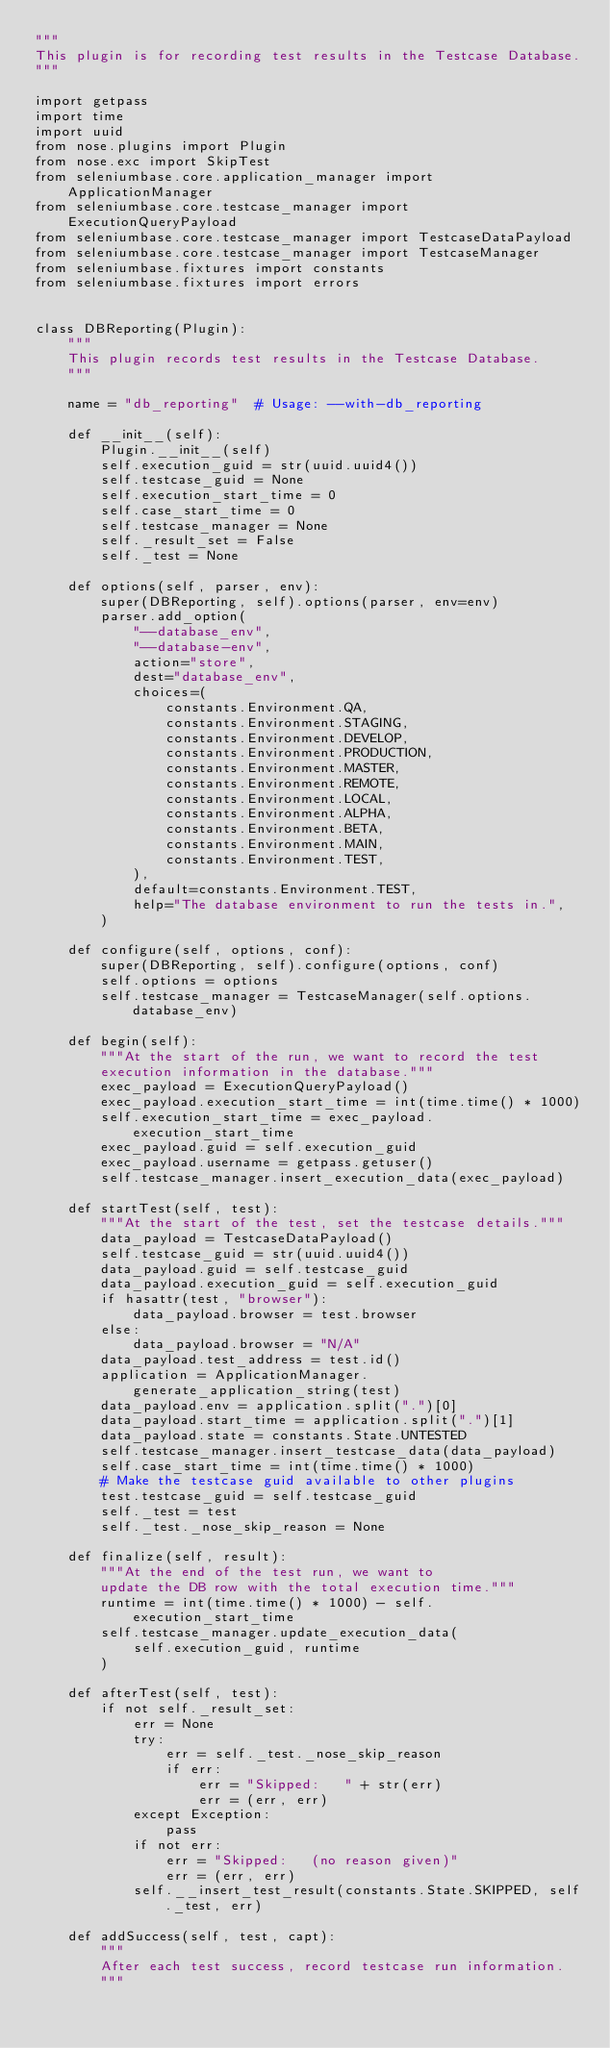Convert code to text. <code><loc_0><loc_0><loc_500><loc_500><_Python_>"""
This plugin is for recording test results in the Testcase Database.
"""

import getpass
import time
import uuid
from nose.plugins import Plugin
from nose.exc import SkipTest
from seleniumbase.core.application_manager import ApplicationManager
from seleniumbase.core.testcase_manager import ExecutionQueryPayload
from seleniumbase.core.testcase_manager import TestcaseDataPayload
from seleniumbase.core.testcase_manager import TestcaseManager
from seleniumbase.fixtures import constants
from seleniumbase.fixtures import errors


class DBReporting(Plugin):
    """
    This plugin records test results in the Testcase Database.
    """

    name = "db_reporting"  # Usage: --with-db_reporting

    def __init__(self):
        Plugin.__init__(self)
        self.execution_guid = str(uuid.uuid4())
        self.testcase_guid = None
        self.execution_start_time = 0
        self.case_start_time = 0
        self.testcase_manager = None
        self._result_set = False
        self._test = None

    def options(self, parser, env):
        super(DBReporting, self).options(parser, env=env)
        parser.add_option(
            "--database_env",
            "--database-env",
            action="store",
            dest="database_env",
            choices=(
                constants.Environment.QA,
                constants.Environment.STAGING,
                constants.Environment.DEVELOP,
                constants.Environment.PRODUCTION,
                constants.Environment.MASTER,
                constants.Environment.REMOTE,
                constants.Environment.LOCAL,
                constants.Environment.ALPHA,
                constants.Environment.BETA,
                constants.Environment.MAIN,
                constants.Environment.TEST,
            ),
            default=constants.Environment.TEST,
            help="The database environment to run the tests in.",
        )

    def configure(self, options, conf):
        super(DBReporting, self).configure(options, conf)
        self.options = options
        self.testcase_manager = TestcaseManager(self.options.database_env)

    def begin(self):
        """At the start of the run, we want to record the test
        execution information in the database."""
        exec_payload = ExecutionQueryPayload()
        exec_payload.execution_start_time = int(time.time() * 1000)
        self.execution_start_time = exec_payload.execution_start_time
        exec_payload.guid = self.execution_guid
        exec_payload.username = getpass.getuser()
        self.testcase_manager.insert_execution_data(exec_payload)

    def startTest(self, test):
        """At the start of the test, set the testcase details."""
        data_payload = TestcaseDataPayload()
        self.testcase_guid = str(uuid.uuid4())
        data_payload.guid = self.testcase_guid
        data_payload.execution_guid = self.execution_guid
        if hasattr(test, "browser"):
            data_payload.browser = test.browser
        else:
            data_payload.browser = "N/A"
        data_payload.test_address = test.id()
        application = ApplicationManager.generate_application_string(test)
        data_payload.env = application.split(".")[0]
        data_payload.start_time = application.split(".")[1]
        data_payload.state = constants.State.UNTESTED
        self.testcase_manager.insert_testcase_data(data_payload)
        self.case_start_time = int(time.time() * 1000)
        # Make the testcase guid available to other plugins
        test.testcase_guid = self.testcase_guid
        self._test = test
        self._test._nose_skip_reason = None

    def finalize(self, result):
        """At the end of the test run, we want to
        update the DB row with the total execution time."""
        runtime = int(time.time() * 1000) - self.execution_start_time
        self.testcase_manager.update_execution_data(
            self.execution_guid, runtime
        )

    def afterTest(self, test):
        if not self._result_set:
            err = None
            try:
                err = self._test._nose_skip_reason
                if err:
                    err = "Skipped:   " + str(err)
                    err = (err, err)
            except Exception:
                pass
            if not err:
                err = "Skipped:   (no reason given)"
                err = (err, err)
            self.__insert_test_result(constants.State.SKIPPED, self._test, err)

    def addSuccess(self, test, capt):
        """
        After each test success, record testcase run information.
        """</code> 